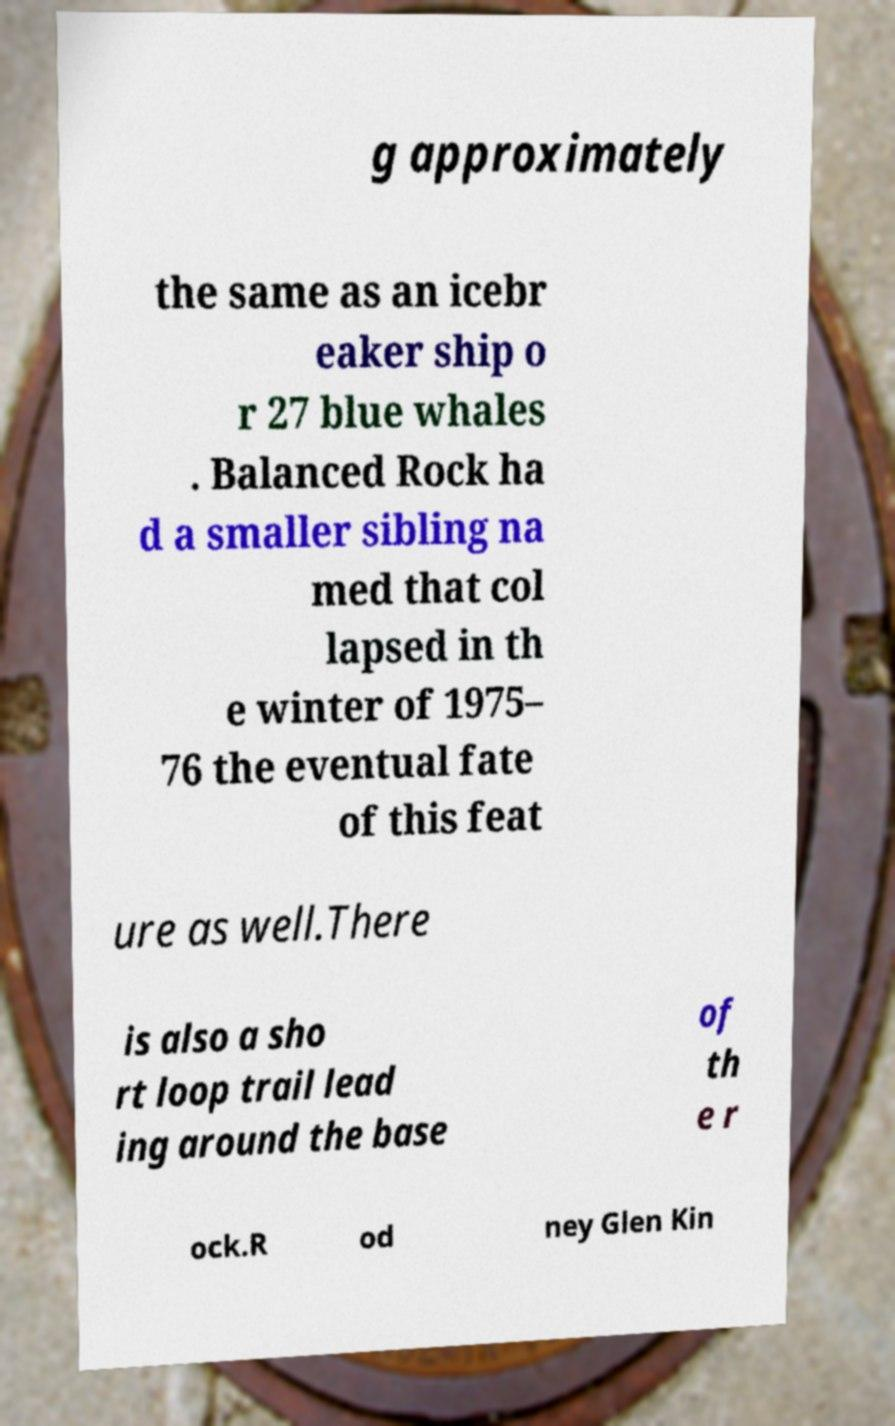Please identify and transcribe the text found in this image. g approximately the same as an icebr eaker ship o r 27 blue whales . Balanced Rock ha d a smaller sibling na med that col lapsed in th e winter of 1975– 76 the eventual fate of this feat ure as well.There is also a sho rt loop trail lead ing around the base of th e r ock.R od ney Glen Kin 